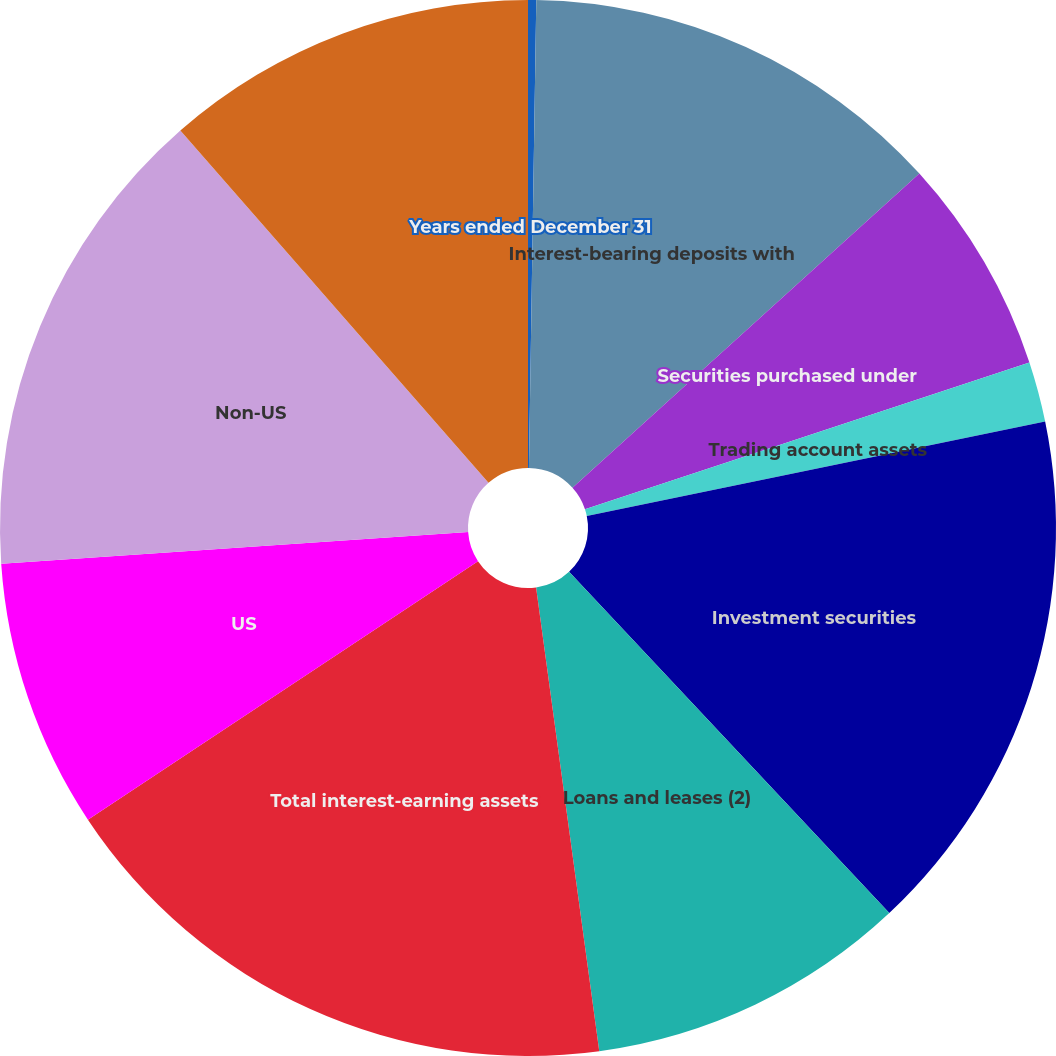Convert chart. <chart><loc_0><loc_0><loc_500><loc_500><pie_chart><fcel>Years ended December 31<fcel>Interest-bearing deposits with<fcel>Securities purchased under<fcel>Trading account assets<fcel>Investment securities<fcel>Loans and leases (2)<fcel>Total interest-earning assets<fcel>US<fcel>Non-US<fcel>Securities sold under<nl><fcel>0.25%<fcel>13.04%<fcel>6.64%<fcel>1.84%<fcel>16.24%<fcel>9.84%<fcel>17.84%<fcel>8.24%<fcel>14.64%<fcel>11.44%<nl></chart> 